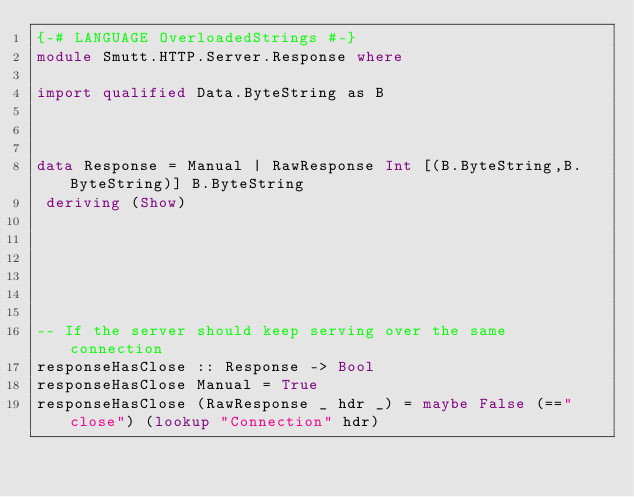Convert code to text. <code><loc_0><loc_0><loc_500><loc_500><_Haskell_>{-# LANGUAGE OverloadedStrings #-}
module Smutt.HTTP.Server.Response where

import qualified Data.ByteString as B



data Response = Manual | RawResponse Int [(B.ByteString,B.ByteString)] B.ByteString
 deriving (Show)






-- If the server should keep serving over the same connection
responseHasClose :: Response -> Bool
responseHasClose Manual = True
responseHasClose (RawResponse _ hdr _) = maybe False (=="close") (lookup "Connection" hdr)

</code> 